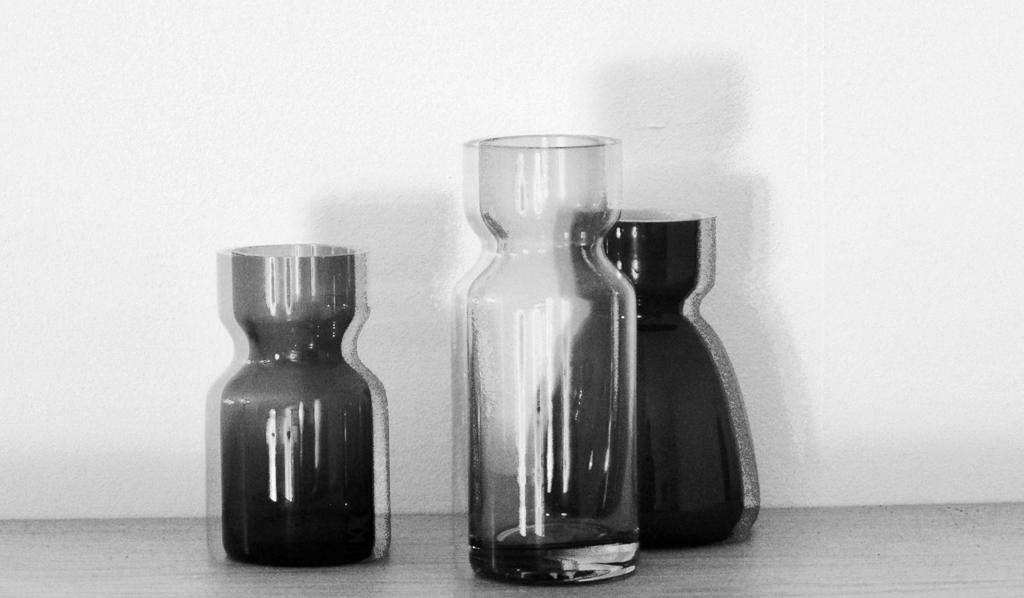What is the color scheme of the image? The image is black and white. How many glass flasks are visible in the image? There are three glass flasks in the image. Where are the glass flasks located in the image? The glass flasks are on the floor. What type of acoustics can be heard coming from the glass flasks in the image? There is no sound or acoustics present in the image, as it is a still photograph. What type of bag is visible in the image? There is no bag present in the image; it features three glass flasks on the floor. 